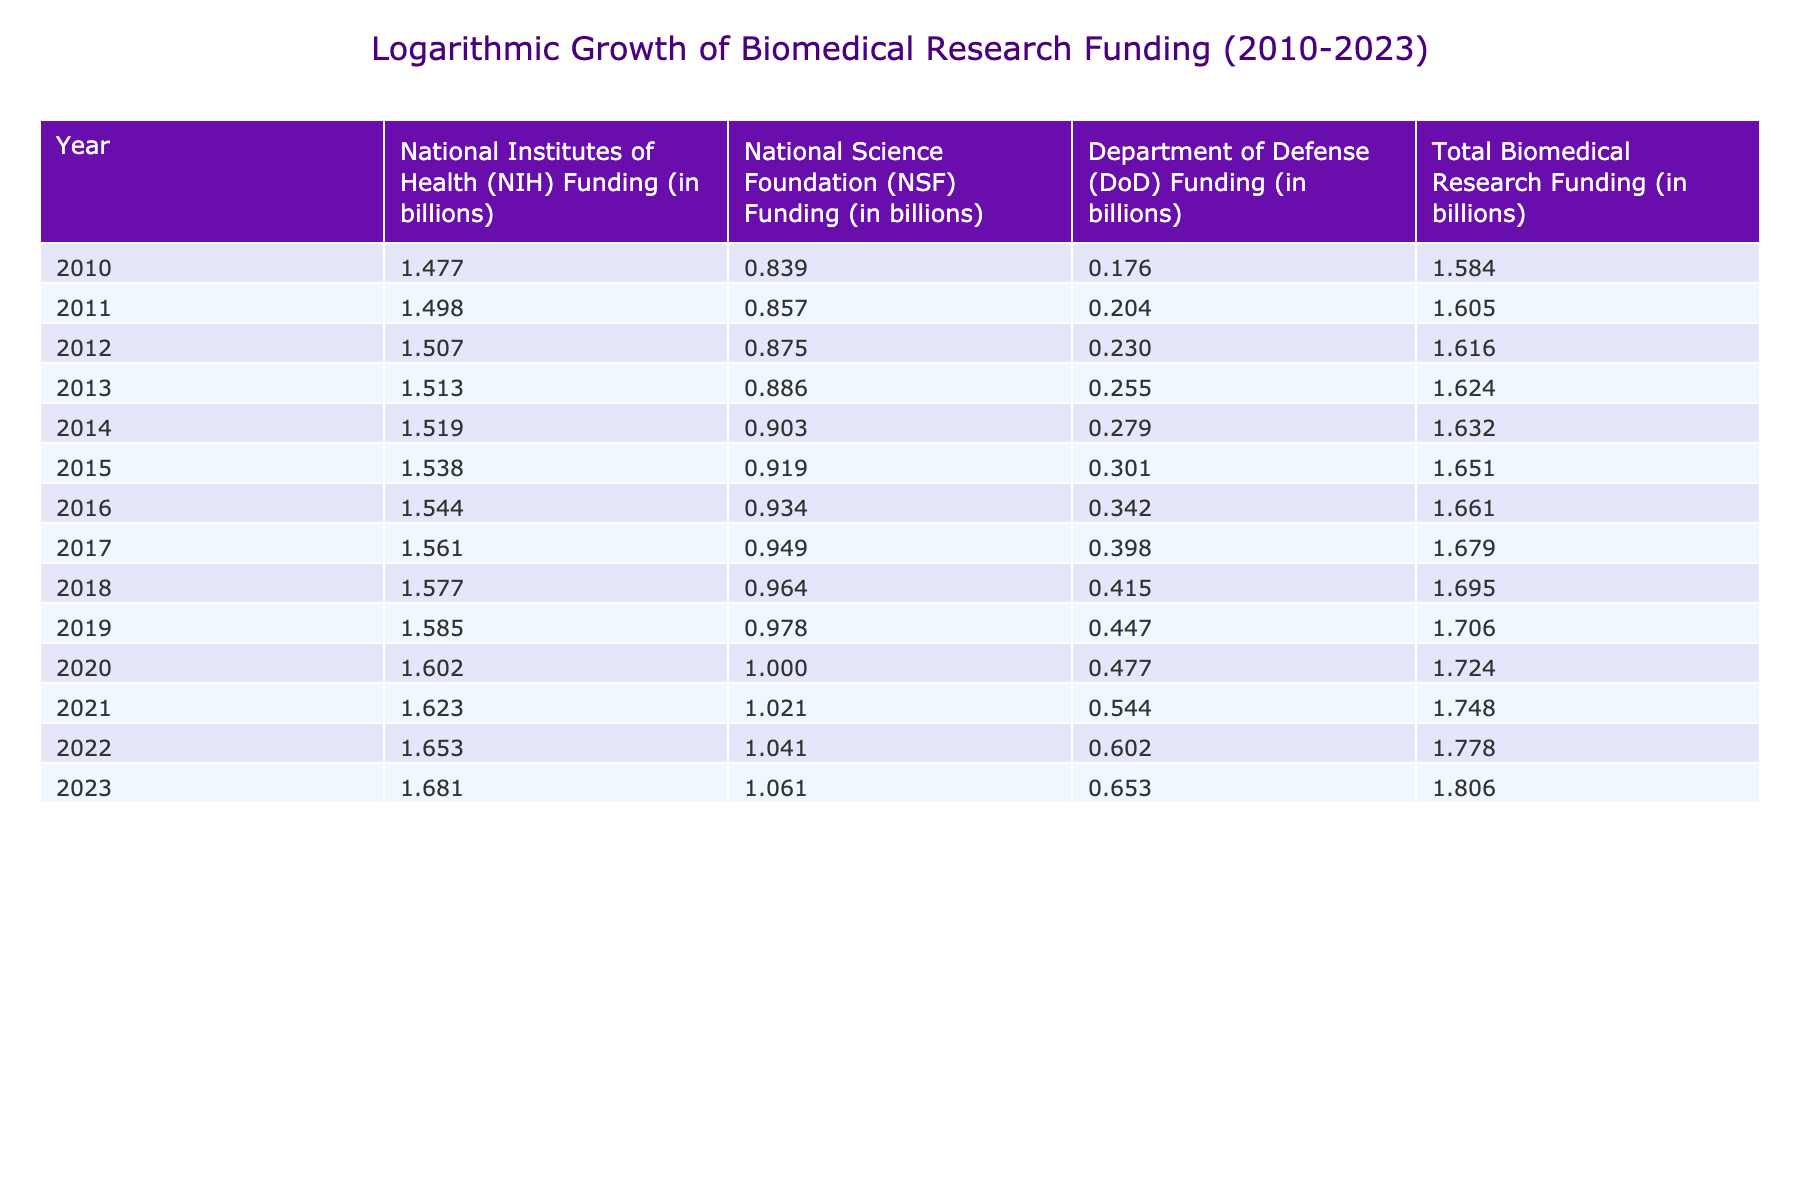What was the total biomedical research funding in 2020? The table shows a specific row for the year 2020, indicating the Total Biomedical Research Funding as 53.0 billion.
Answer: 53.0 billion What is the difference between NIH funding in 2023 and NIH funding in 2010? The NIH funding for 2023 is 48.0 billion, while for 2010 it is 30.0 billion. The difference is 48.0 - 30.0 = 18.0 billion.
Answer: 18.0 billion Did the NSF funding increase every year from 2010 to 2023? By reviewing the NSF funding for each year in the table, we find that it shows a consistent increase each year, with the values growing from 6.9 billion in 2010 to 11.5 billion in 2023.
Answer: Yes What was the average total biomedical research funding from 2010 to 2023? To find the average, we sum the total funding from all years (38.4 + 40.3 + 41.3 + 42.1 + 42.9 + 44.8 + 45.8 + 47.8 + 49.6 + 50.8 + 53.0 + 56.0 + 60.0 + 64.0 =  654.0), and divide by the number of years (14). Hence, the average is 654.0 / 14 = 46.71 billion.
Answer: 46.71 billion What years had a total funding above 60 billion? Reviewing the total funding values, we see that 2022 (60.0 billion) and 2023 (64.0 billion) were the only years above 60 billion, since 2022 is exactly 60 billion and 2023 exceeds it.
Answer: 2022 and 2023 What was the percentage increase in total biomedical research funding from 2010 to 2023? The total funding in 2023 is 64.0 billion and in 2010 is 38.4 billion. The increase is (64.0 - 38.4) = 25.6 billion. To find the percentage, the formula is (Increase / Original) x 100 = (25.6 / 38.4) x 100 = 66.67%.
Answer: 66.67% 